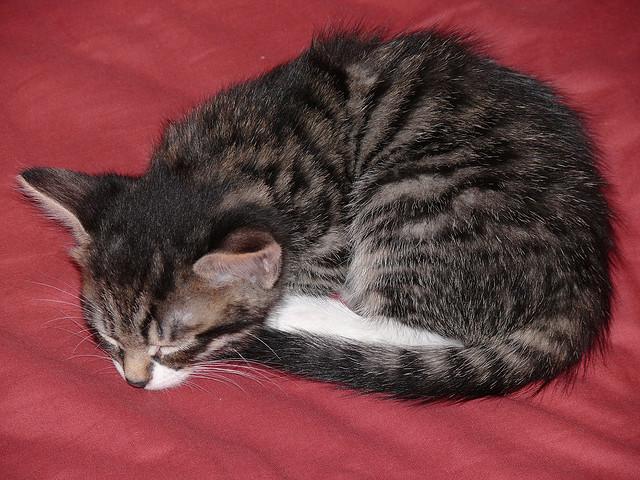Is the cat asleep or awake?
Keep it brief. Asleep. What kind of cat is this?
Concise answer only. Kitten. Is this can sleeping?
Write a very short answer. Yes. Is the kitten asleep?
Quick response, please. Yes. Is this an adult cat?
Quick response, please. No. 